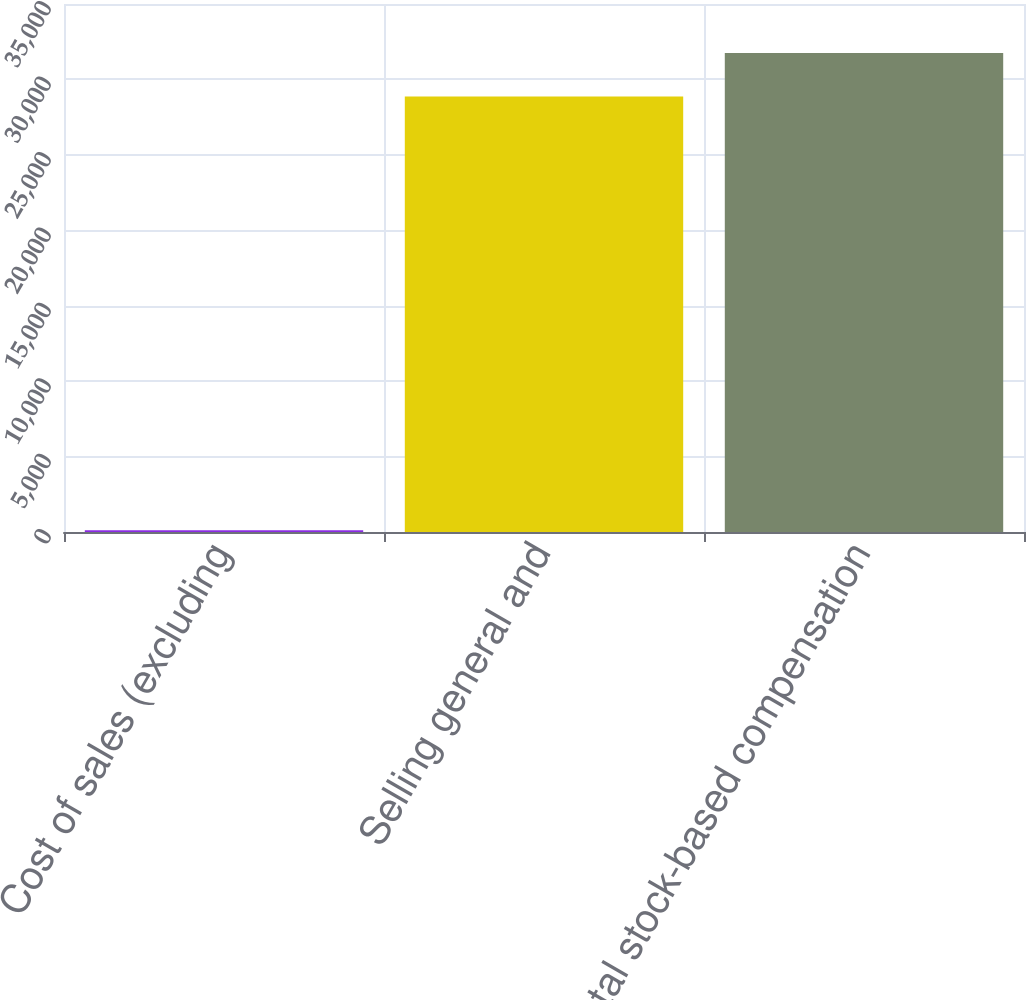Convert chart. <chart><loc_0><loc_0><loc_500><loc_500><bar_chart><fcel>Cost of sales (excluding<fcel>Selling general and<fcel>Total stock-based compensation<nl><fcel>110<fcel>28866<fcel>31752.6<nl></chart> 